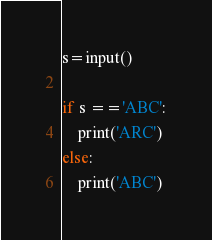Convert code to text. <code><loc_0><loc_0><loc_500><loc_500><_Python_>s=input()

if s =='ABC':
    print('ARC')
else:
    print('ABC')</code> 